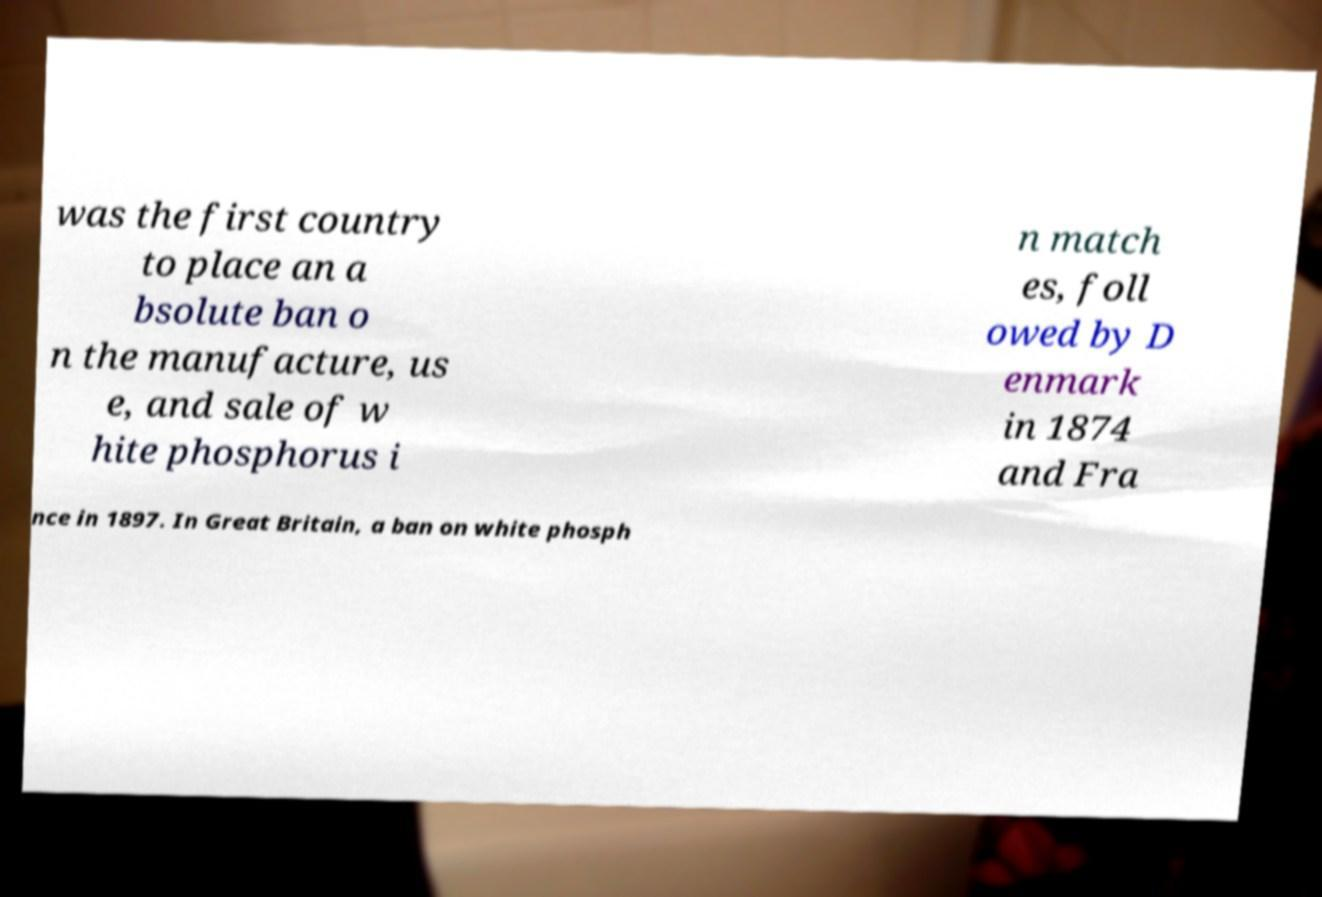For documentation purposes, I need the text within this image transcribed. Could you provide that? was the first country to place an a bsolute ban o n the manufacture, us e, and sale of w hite phosphorus i n match es, foll owed by D enmark in 1874 and Fra nce in 1897. In Great Britain, a ban on white phosph 